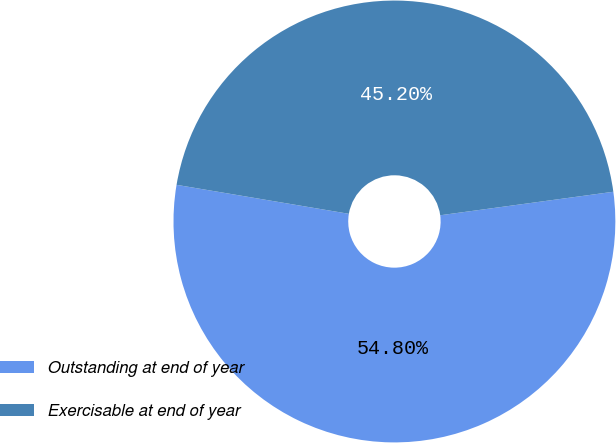Convert chart to OTSL. <chart><loc_0><loc_0><loc_500><loc_500><pie_chart><fcel>Outstanding at end of year<fcel>Exercisable at end of year<nl><fcel>54.8%<fcel>45.2%<nl></chart> 